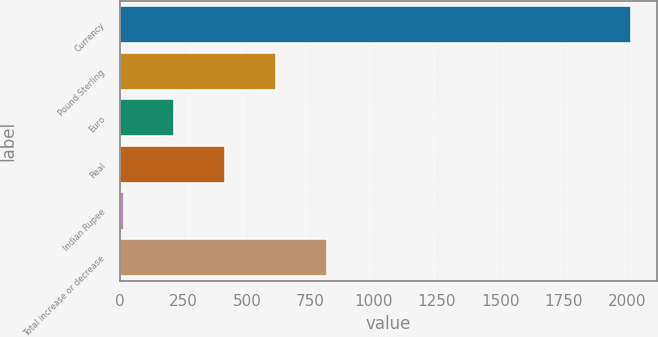Convert chart to OTSL. <chart><loc_0><loc_0><loc_500><loc_500><bar_chart><fcel>Currency<fcel>Pound Sterling<fcel>Euro<fcel>Real<fcel>Indian Rupee<fcel>Total increase or decrease<nl><fcel>2017<fcel>614.9<fcel>214.3<fcel>414.6<fcel>14<fcel>815.2<nl></chart> 